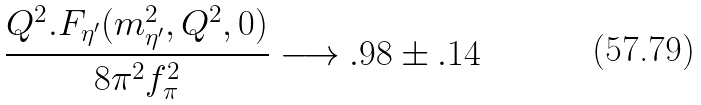<formula> <loc_0><loc_0><loc_500><loc_500>\frac { Q ^ { 2 } . F _ { \eta ^ { \prime } } ( m _ { \eta ^ { \prime } } ^ { 2 } , Q ^ { 2 } , 0 ) } { 8 \pi ^ { 2 } f _ { \pi } ^ { 2 } } \longrightarrow . 9 8 \pm . 1 4</formula> 